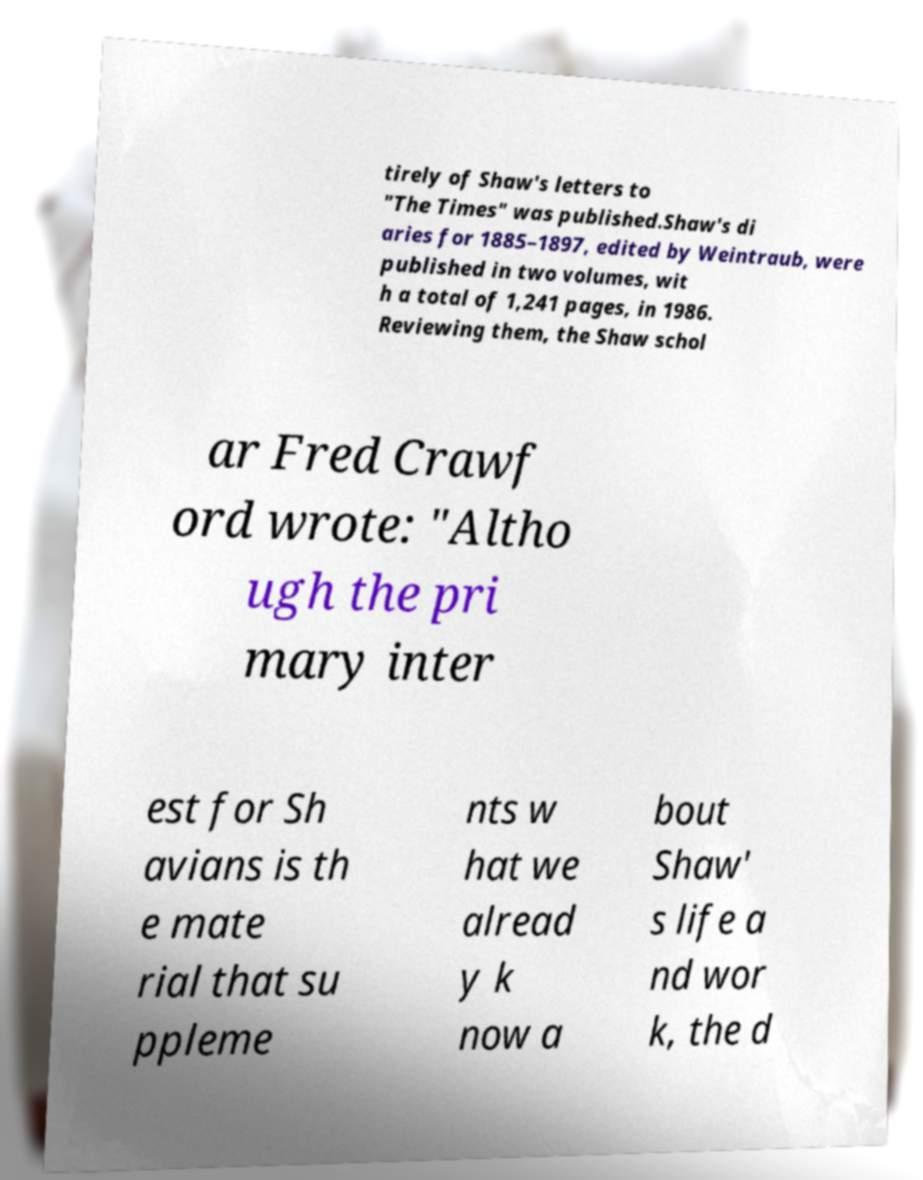Can you accurately transcribe the text from the provided image for me? tirely of Shaw's letters to "The Times" was published.Shaw's di aries for 1885–1897, edited by Weintraub, were published in two volumes, wit h a total of 1,241 pages, in 1986. Reviewing them, the Shaw schol ar Fred Crawf ord wrote: "Altho ugh the pri mary inter est for Sh avians is th e mate rial that su ppleme nts w hat we alread y k now a bout Shaw' s life a nd wor k, the d 